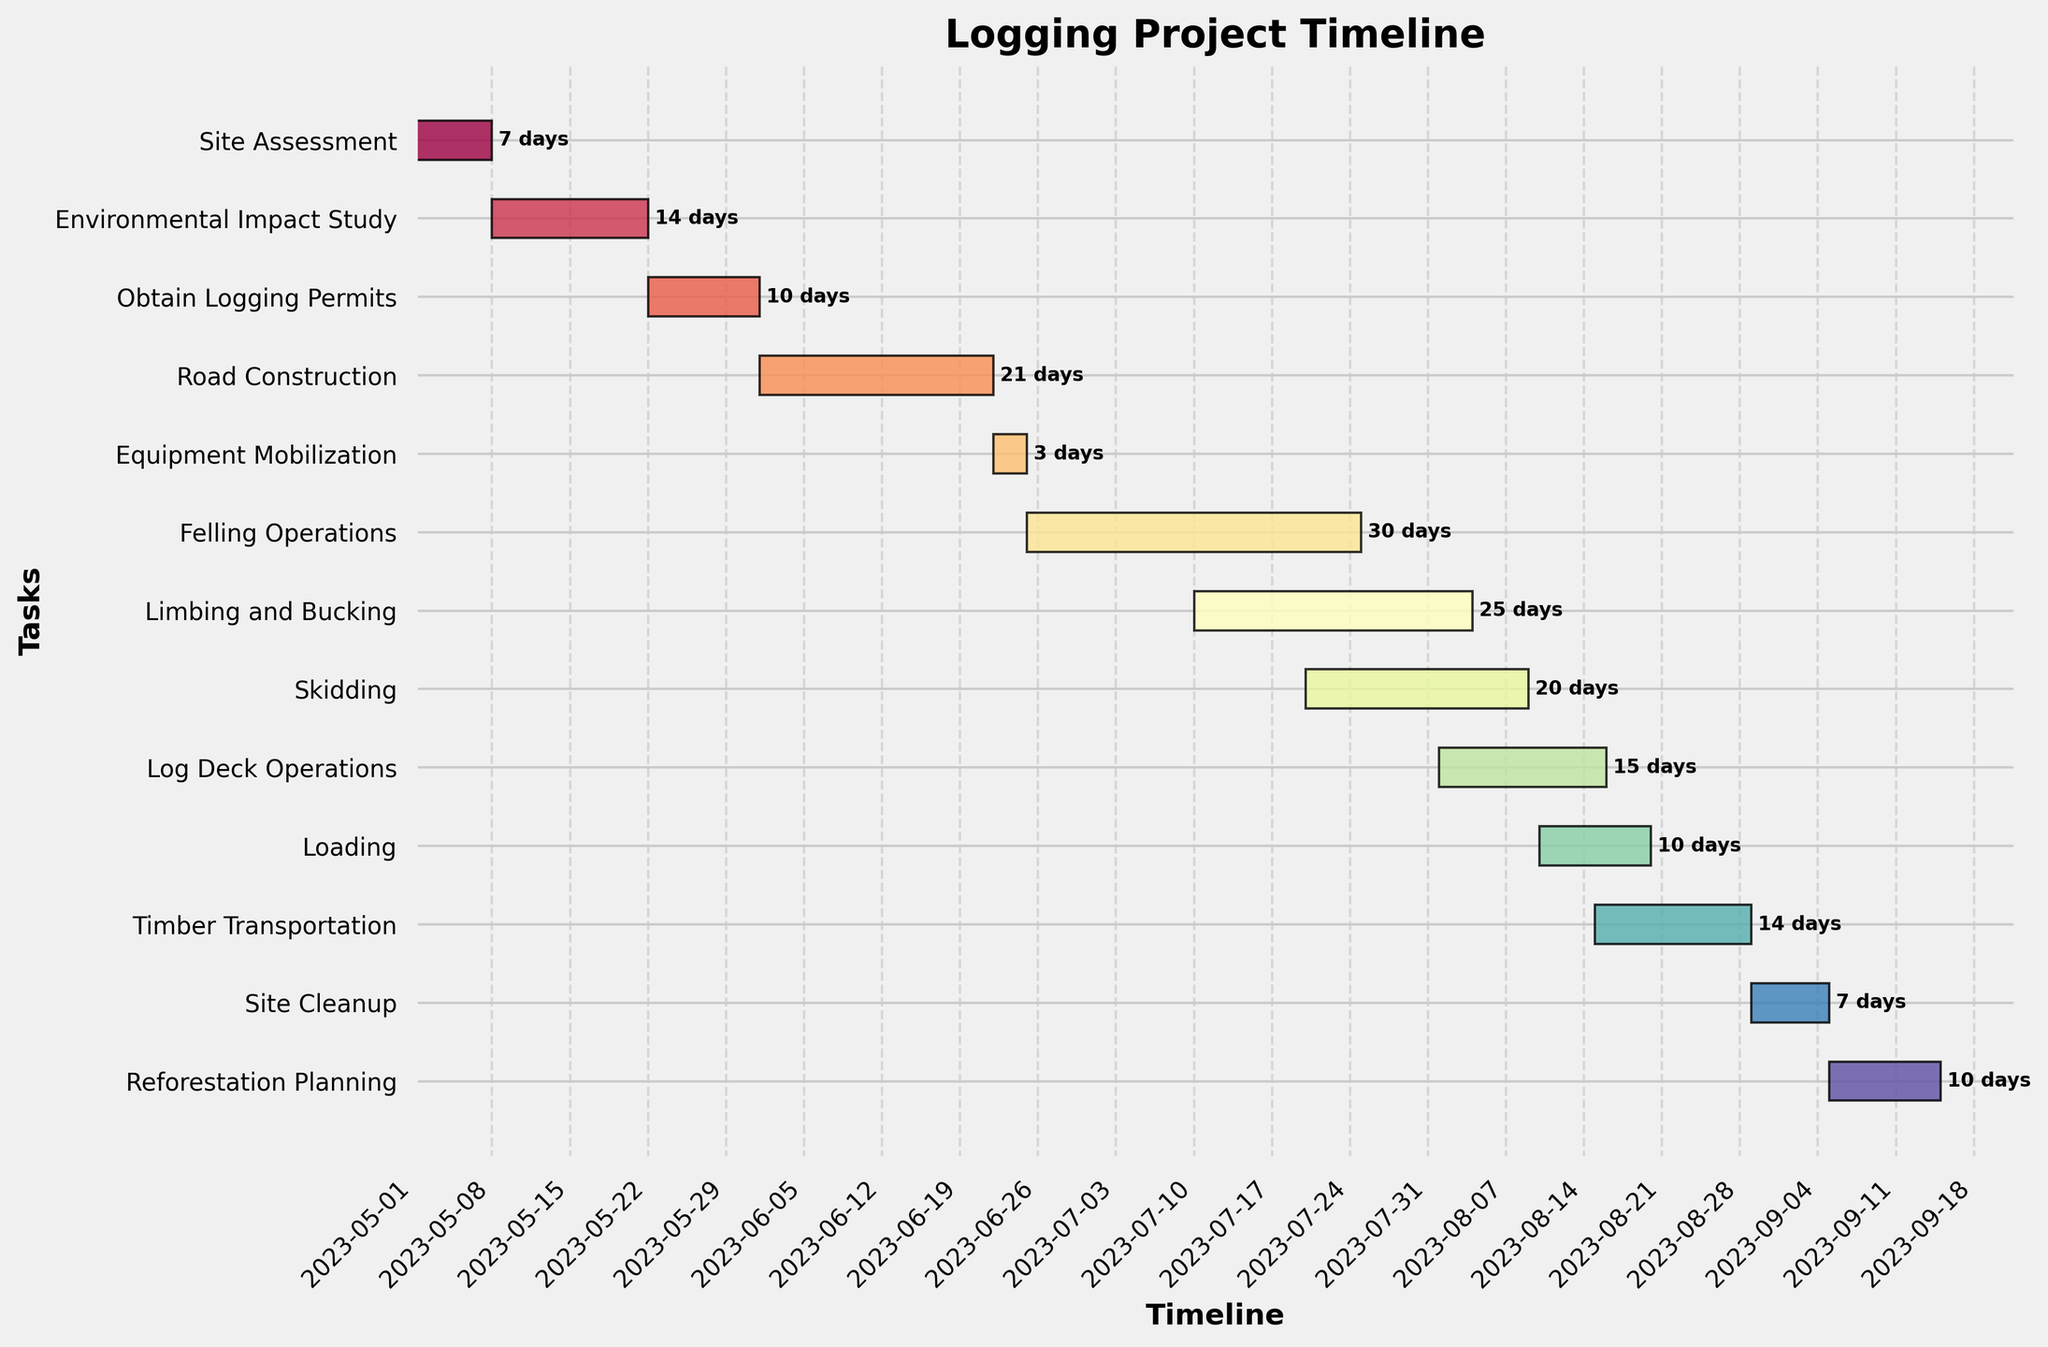What is the title of the figure? The title is displayed at the top of the Gantt Chart.
Answer: Logging Project Timeline Which task has the longest duration? To find the longest duration, look at the length of the bars. Felling Operations has the longest bar.
Answer: Felling Operations How many tasks are there in total? Count the number of distinct bars or tasks listed on the y-axis. There are 13 tasks.
Answer: 13 Which task starts first? Look at the position of the tasks on the x-axis. The task that starts the earliest is at the far left.
Answer: Site Assessment What is the duration of the Timber Transportation task? Check the label at the end of the Timber Transportation bar. It reads '14 days'.
Answer: 14 days When does the Felling Operations task end? The end date is depicted at the end of the bar for Felling Operations. It starts on June 25 and lasts 30 days, so it ends on July 25.
Answer: 2023-07-25 Which tasks overlap directly with the Environmental Impact Study? Identify tasks whose bars intersect with the Environmental Impact Study task running from May 8 to May 22. Obtain Logging Permits overlaps.
Answer: Obtain Logging Permits What is the total duration from the start of the project to the end of Site Cleanup? Track from the start of Site Assessment on May 1 to the end of Site Cleanup on September 1. That interval covers 123 days.
Answer: 123 days Which task starts immediately after Road Construction? Look at the task positioned immediately after the Road Construction bar, which is Equipment Mobilization starting on June 22.
Answer: Equipment Mobilization Which task follows directly after Loading? Identify the task that starts immediately after the Loading task which ends on August 20. Timber Transportation starts next on August 15.
Answer: Timber Transportation 